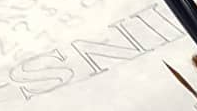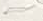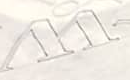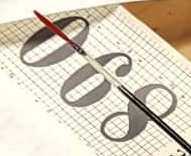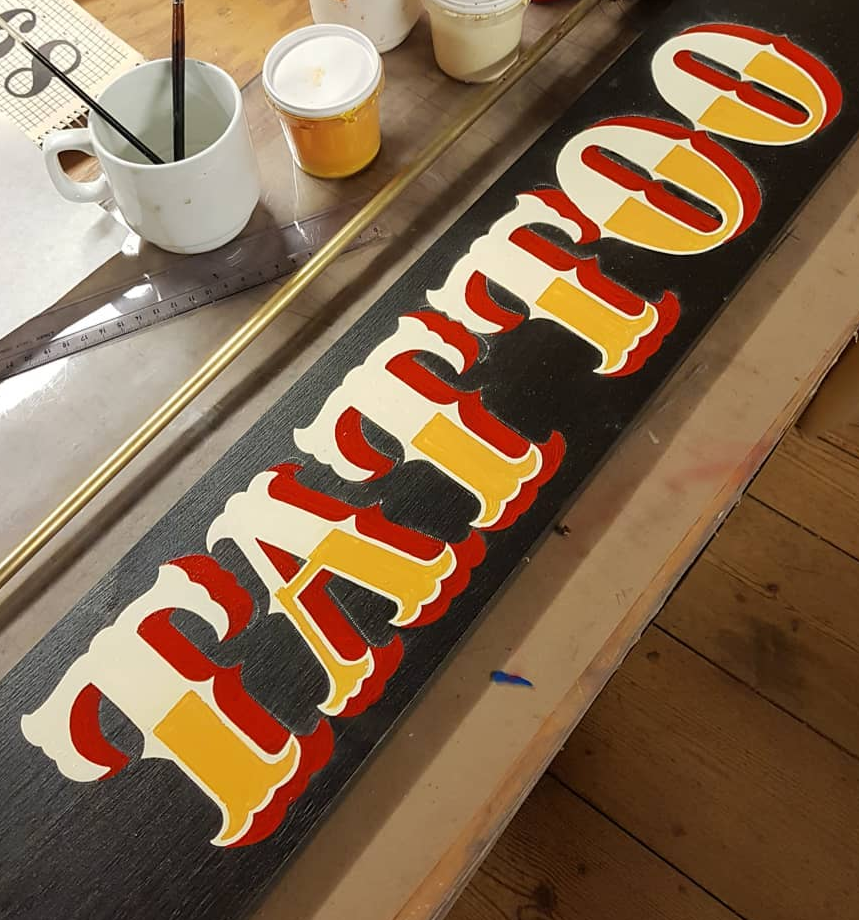Read the text from these images in sequence, separated by a semicolon. INS; ~; W; 890; TATTOO 